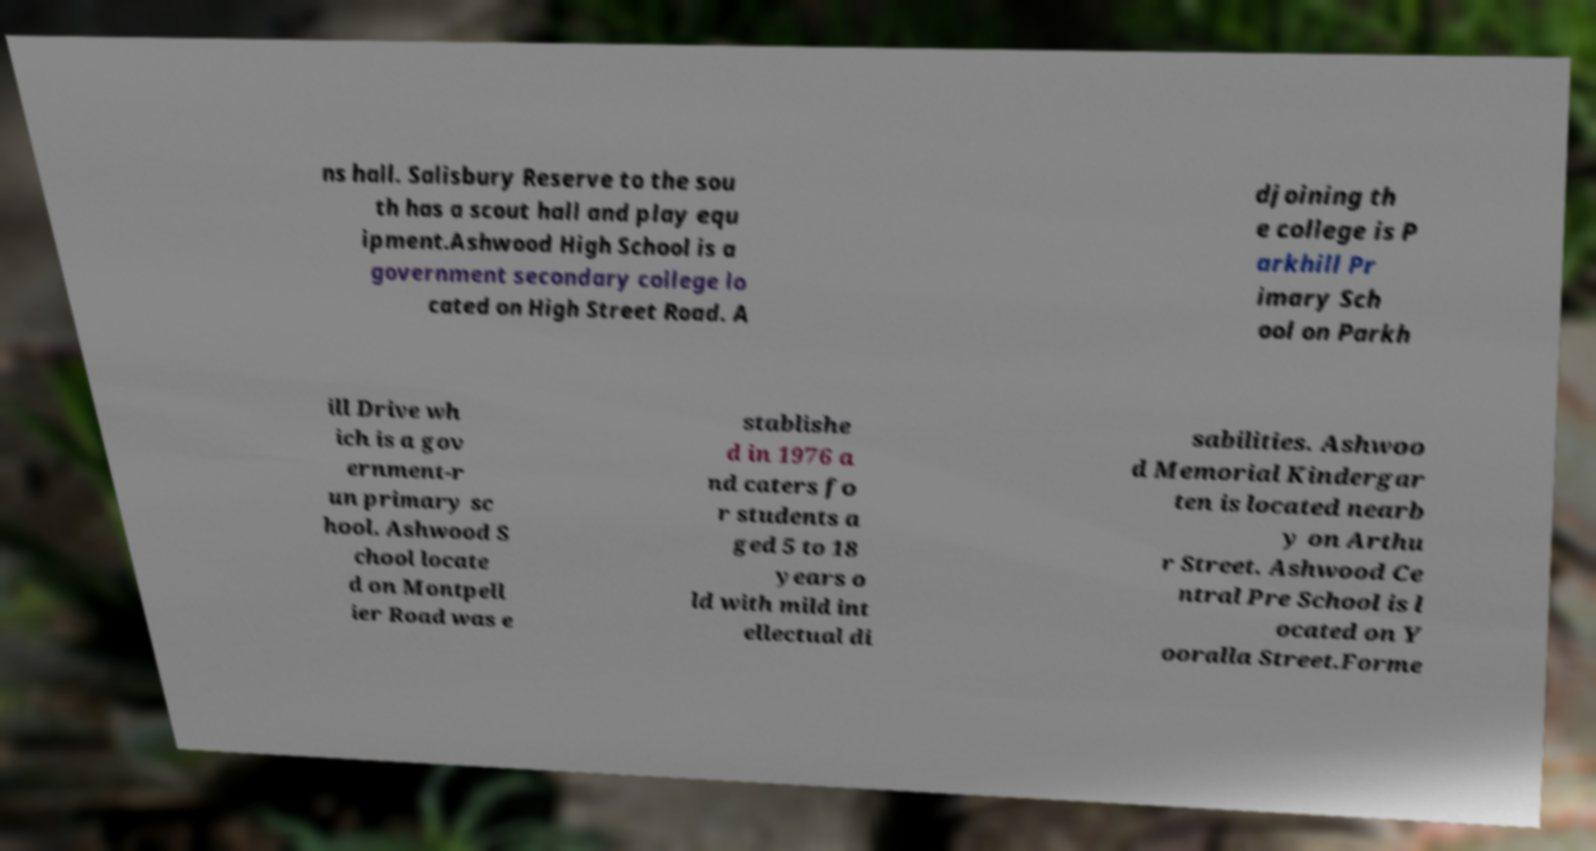Can you accurately transcribe the text from the provided image for me? ns hall. Salisbury Reserve to the sou th has a scout hall and play equ ipment.Ashwood High School is a government secondary college lo cated on High Street Road. A djoining th e college is P arkhill Pr imary Sch ool on Parkh ill Drive wh ich is a gov ernment-r un primary sc hool. Ashwood S chool locate d on Montpell ier Road was e stablishe d in 1976 a nd caters fo r students a ged 5 to 18 years o ld with mild int ellectual di sabilities. Ashwoo d Memorial Kindergar ten is located nearb y on Arthu r Street. Ashwood Ce ntral Pre School is l ocated on Y ooralla Street.Forme 